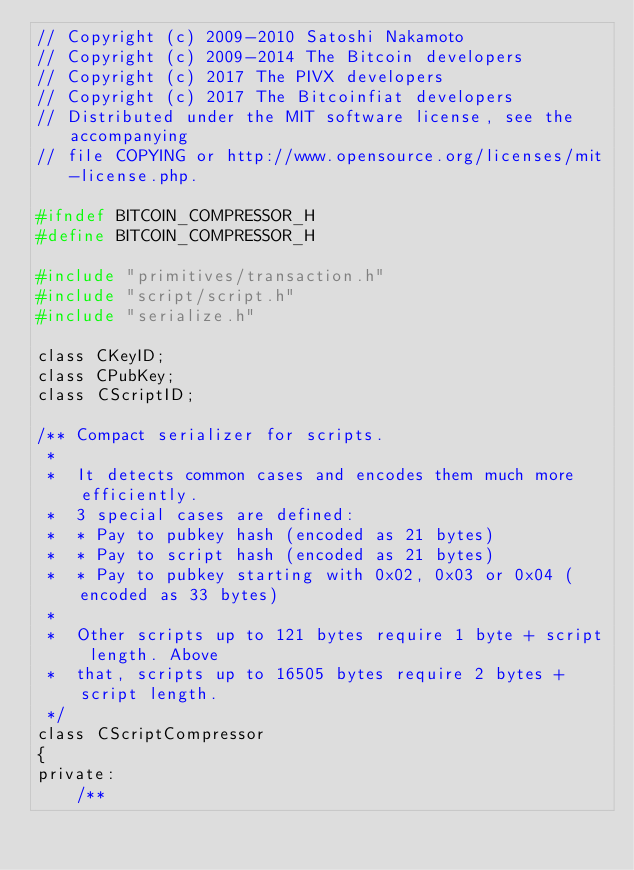<code> <loc_0><loc_0><loc_500><loc_500><_C_>// Copyright (c) 2009-2010 Satoshi Nakamoto
// Copyright (c) 2009-2014 The Bitcoin developers
// Copyright (c) 2017 The PIVX developers
// Copyright (c) 2017 The Bitcoinfiat developers
// Distributed under the MIT software license, see the accompanying
// file COPYING or http://www.opensource.org/licenses/mit-license.php.

#ifndef BITCOIN_COMPRESSOR_H
#define BITCOIN_COMPRESSOR_H

#include "primitives/transaction.h"
#include "script/script.h"
#include "serialize.h"

class CKeyID;
class CPubKey;
class CScriptID;

/** Compact serializer for scripts.
 *
 *  It detects common cases and encodes them much more efficiently.
 *  3 special cases are defined:
 *  * Pay to pubkey hash (encoded as 21 bytes)
 *  * Pay to script hash (encoded as 21 bytes)
 *  * Pay to pubkey starting with 0x02, 0x03 or 0x04 (encoded as 33 bytes)
 *
 *  Other scripts up to 121 bytes require 1 byte + script length. Above
 *  that, scripts up to 16505 bytes require 2 bytes + script length.
 */
class CScriptCompressor
{
private:
    /**</code> 